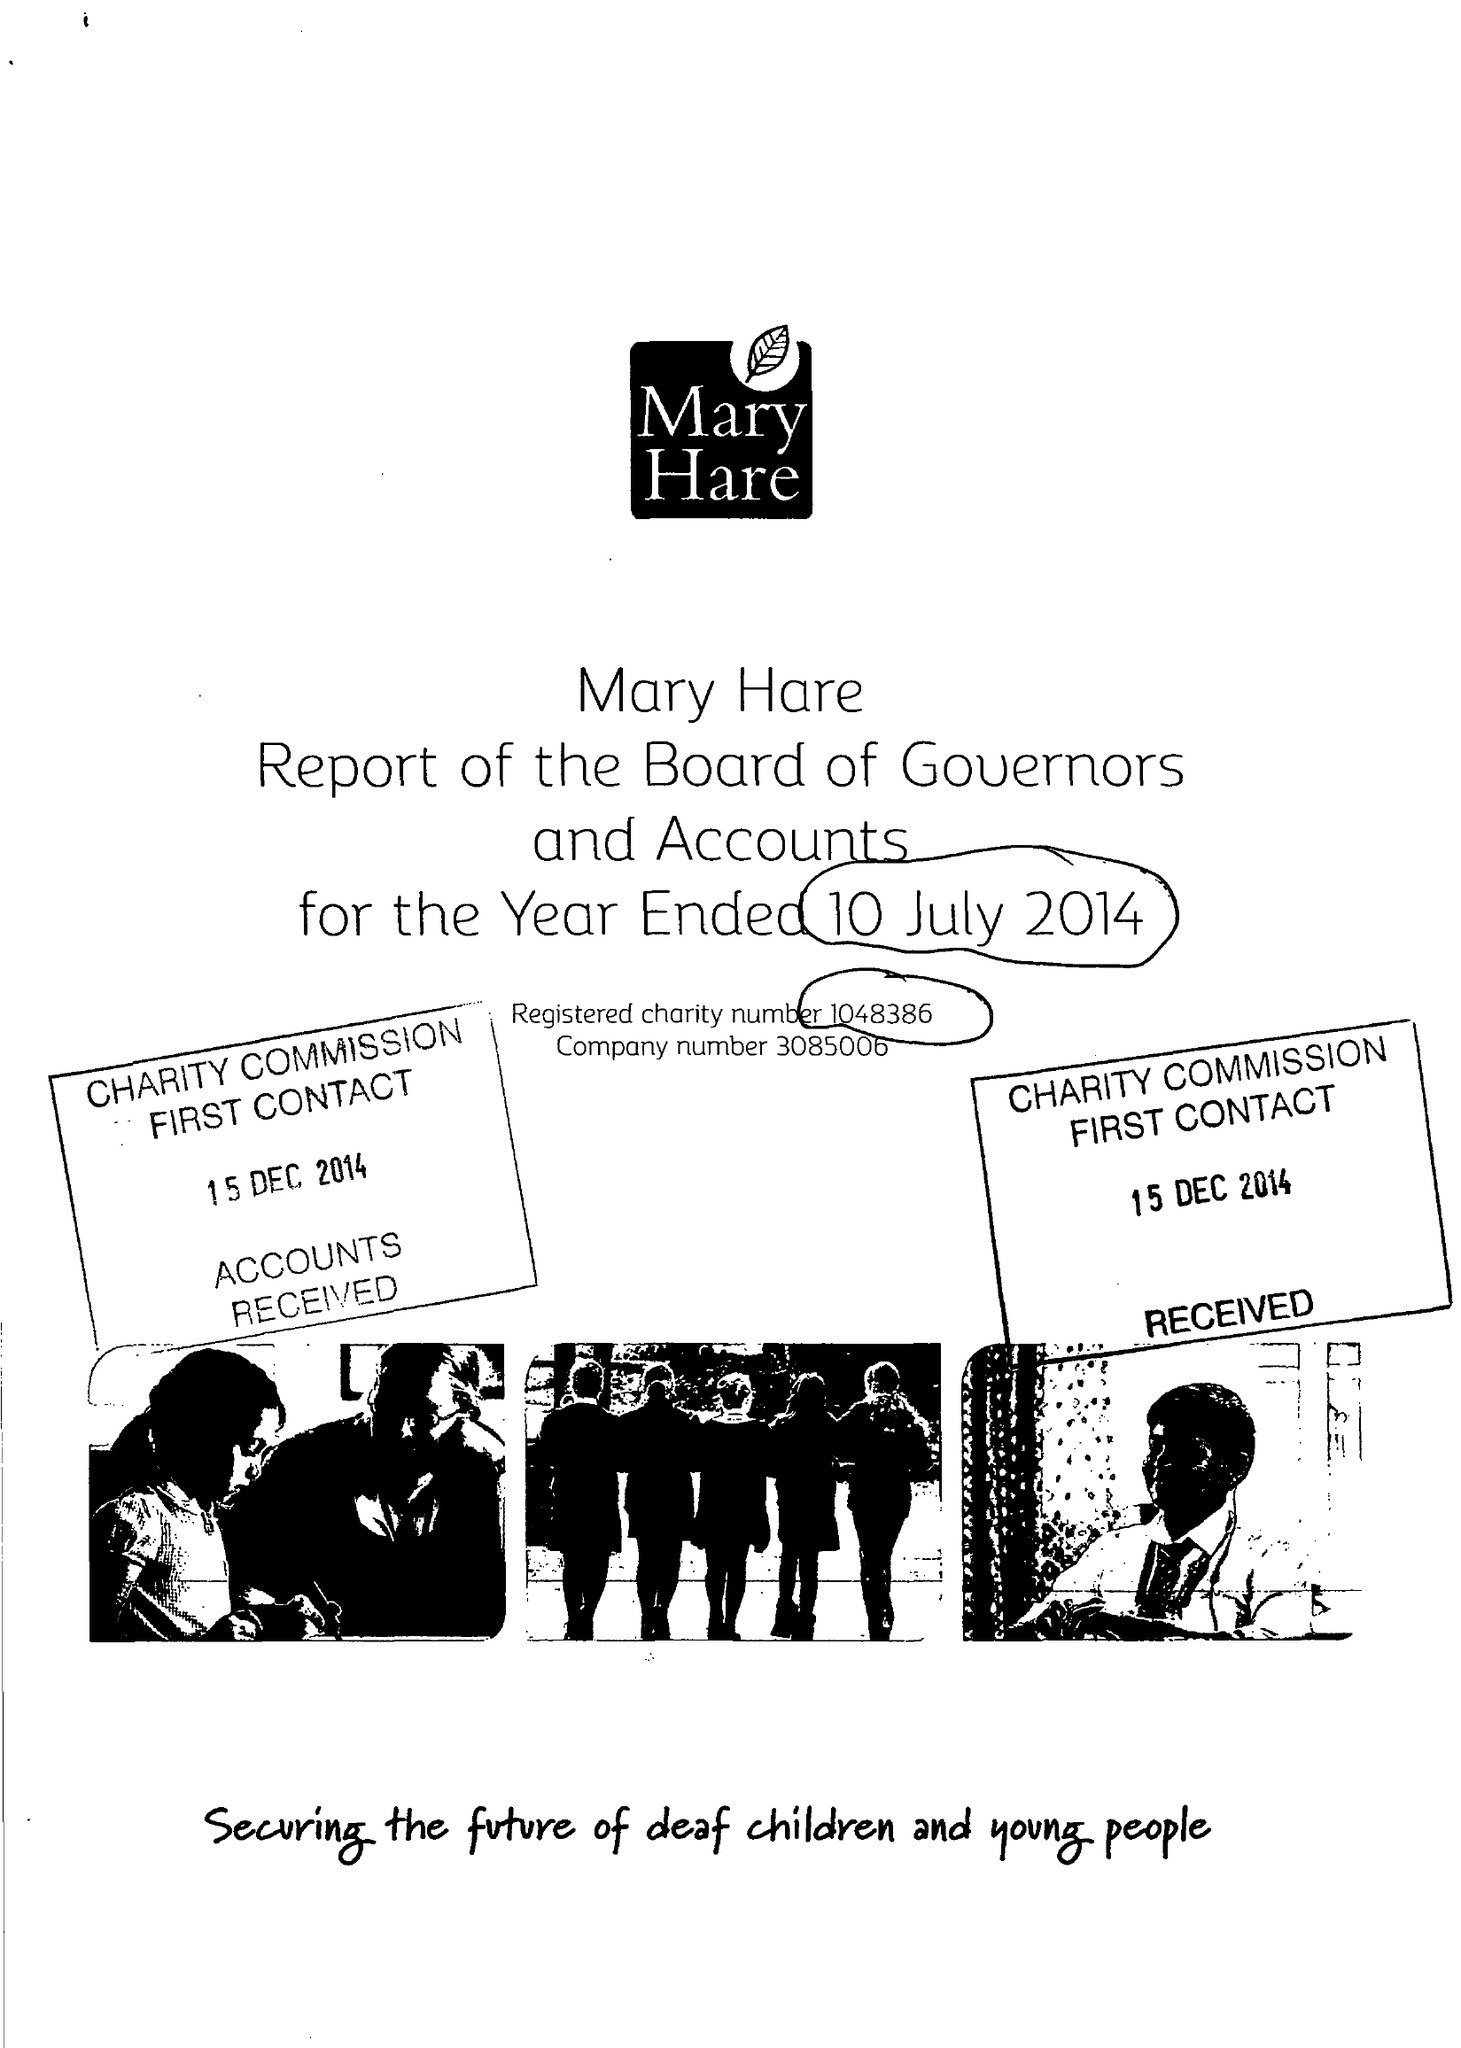What is the value for the address__postcode?
Answer the question using a single word or phrase. RG14 3BQ 